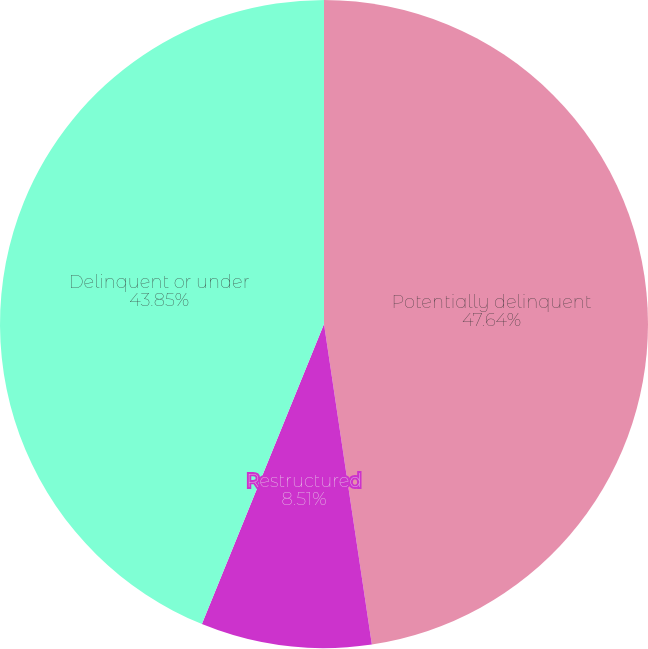Convert chart. <chart><loc_0><loc_0><loc_500><loc_500><pie_chart><fcel>Potentially delinquent<fcel>Restructured<fcel>Delinquent or under<nl><fcel>47.64%<fcel>8.51%<fcel>43.85%<nl></chart> 